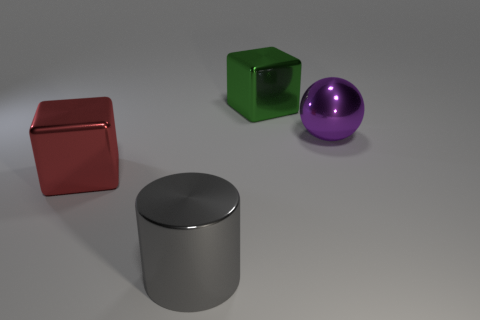What number of big things are either red metallic things or purple metallic spheres?
Ensure brevity in your answer.  2. There is a green thing that is the same material as the big purple object; what shape is it?
Make the answer very short. Cube. Are there fewer metal cylinders in front of the large cylinder than large shiny cylinders?
Keep it short and to the point. Yes. Is the shape of the big green metallic object the same as the large red metal object?
Your response must be concise. Yes. How many matte things are either large balls or large green balls?
Your answer should be very brief. 0. Are there any gray cylinders of the same size as the purple shiny ball?
Provide a succinct answer. Yes. How many green objects are the same size as the gray metallic cylinder?
Offer a terse response. 1. What number of objects are big purple rubber cubes or big things that are behind the large gray cylinder?
Your response must be concise. 3. What color is the big metal ball?
Give a very brief answer. Purple. What material is the thing behind the object that is to the right of the big block that is behind the purple object made of?
Provide a short and direct response. Metal. 